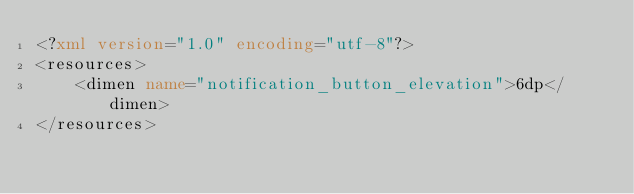<code> <loc_0><loc_0><loc_500><loc_500><_XML_><?xml version="1.0" encoding="utf-8"?>
<resources>
    <dimen name="notification_button_elevation">6dp</dimen>
</resources></code> 